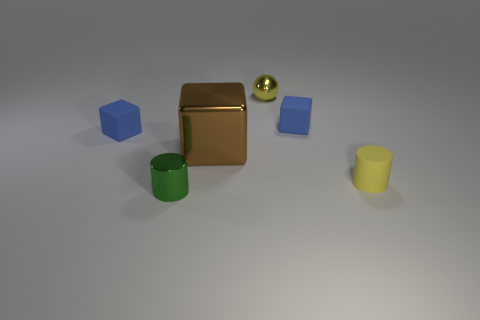Subtract all small matte cubes. How many cubes are left? 1 Subtract 1 blocks. How many blocks are left? 2 Add 2 yellow matte objects. How many objects exist? 8 Subtract all blue cubes. How many cubes are left? 1 Add 4 tiny blue rubber things. How many tiny blue rubber things exist? 6 Subtract 0 red blocks. How many objects are left? 6 Subtract all cylinders. How many objects are left? 4 Subtract all yellow cubes. Subtract all green balls. How many cubes are left? 3 Subtract all yellow balls. How many green cylinders are left? 1 Subtract all red metal objects. Subtract all tiny blue matte objects. How many objects are left? 4 